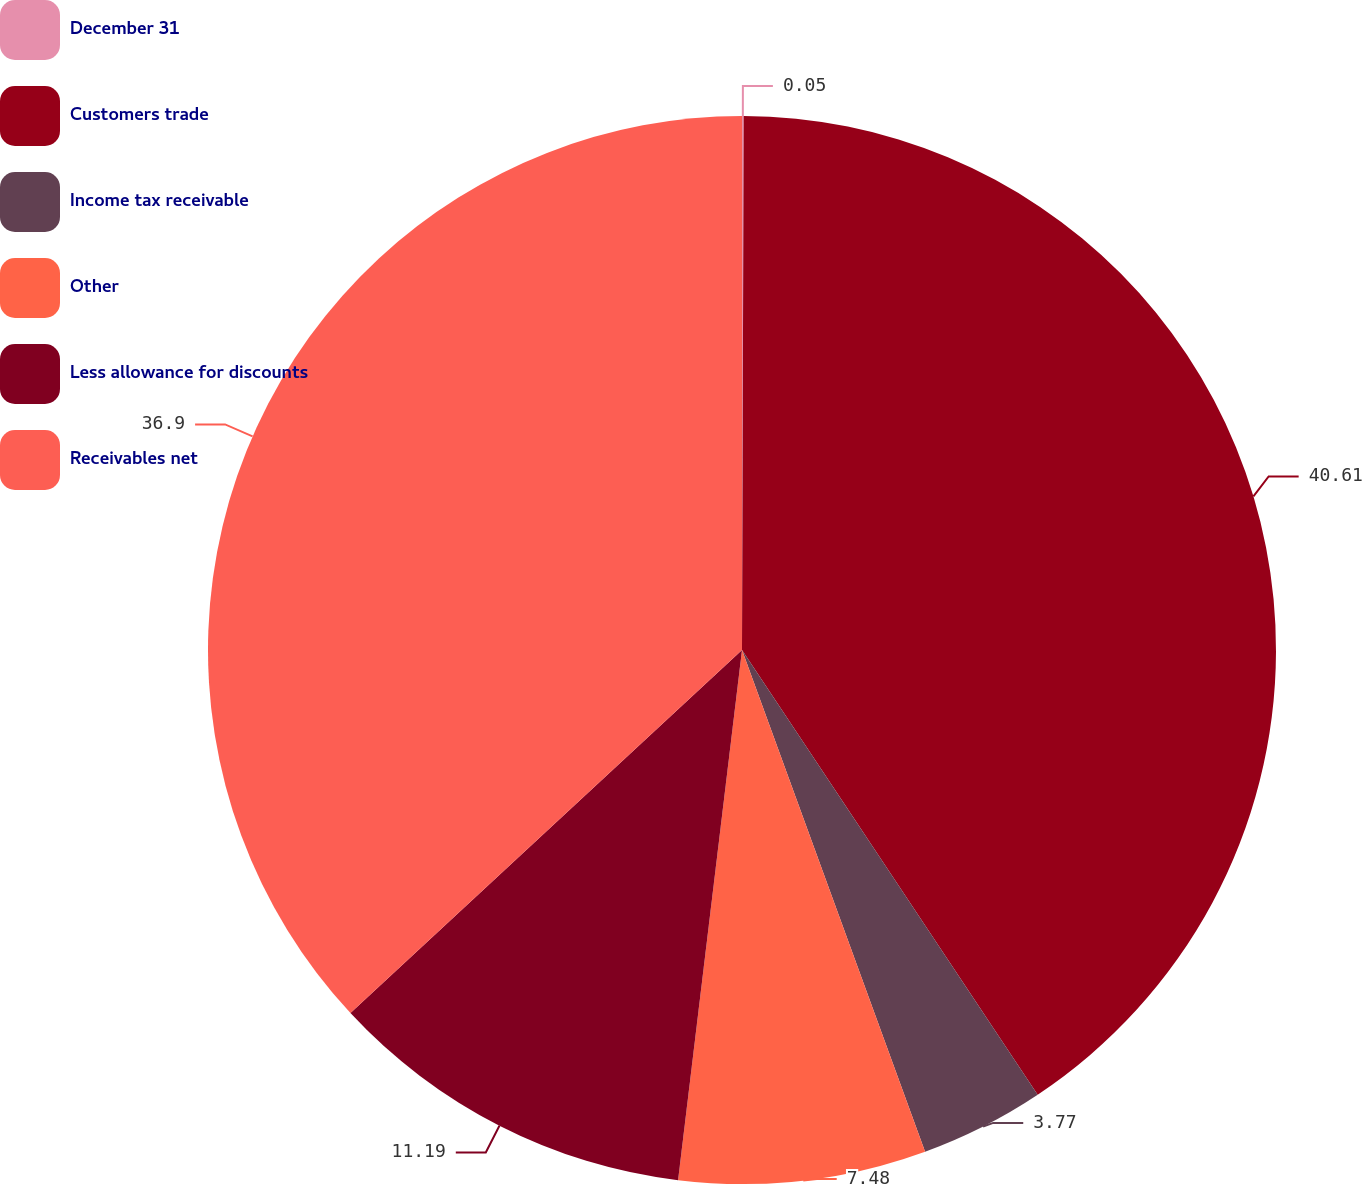Convert chart to OTSL. <chart><loc_0><loc_0><loc_500><loc_500><pie_chart><fcel>December 31<fcel>Customers trade<fcel>Income tax receivable<fcel>Other<fcel>Less allowance for discounts<fcel>Receivables net<nl><fcel>0.05%<fcel>40.61%<fcel>3.77%<fcel>7.48%<fcel>11.19%<fcel>36.9%<nl></chart> 